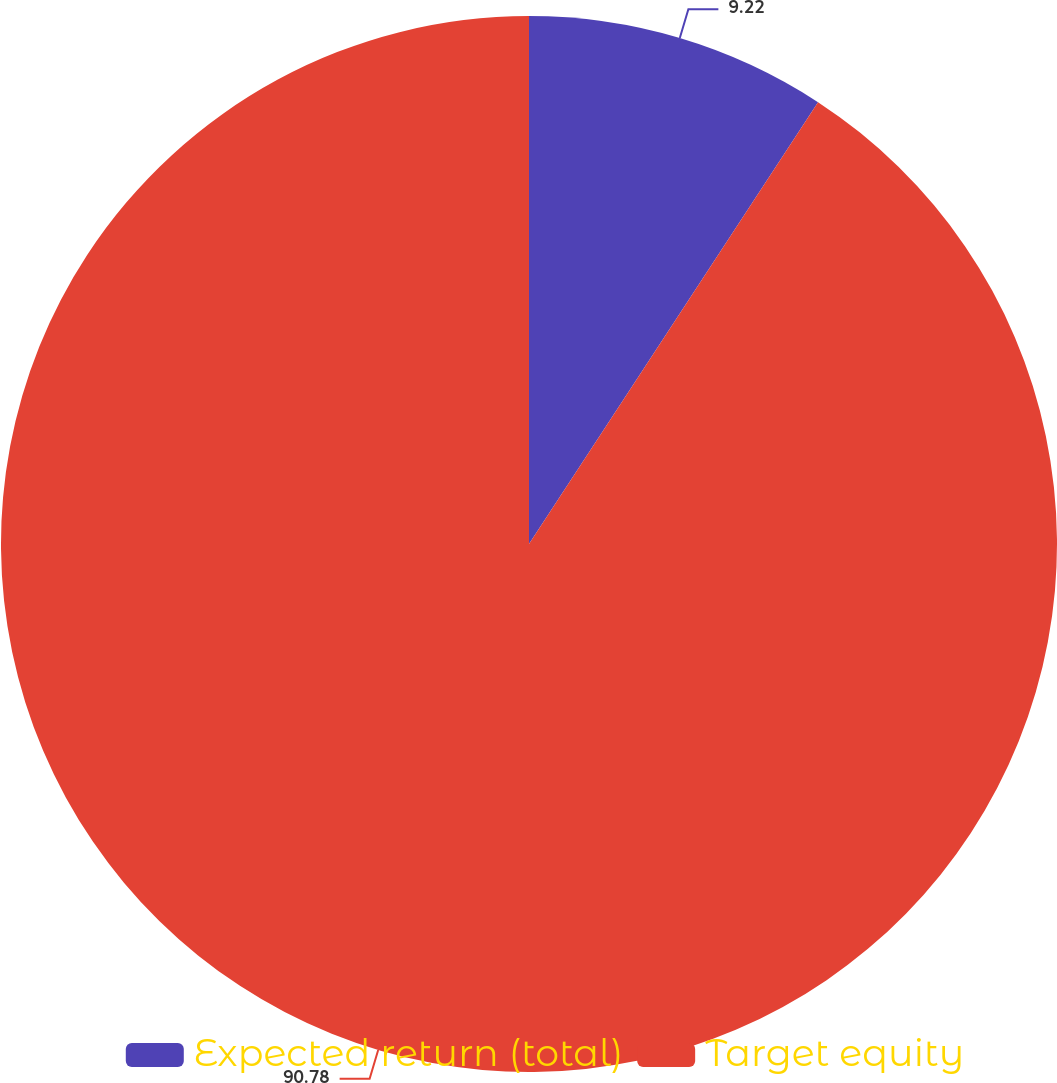Convert chart. <chart><loc_0><loc_0><loc_500><loc_500><pie_chart><fcel>Expected return (total)<fcel>Target equity<nl><fcel>9.22%<fcel>90.78%<nl></chart> 